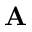<formula> <loc_0><loc_0><loc_500><loc_500>A</formula> 